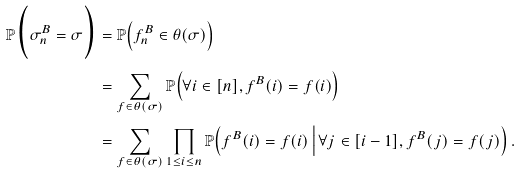<formula> <loc_0><loc_0><loc_500><loc_500>\mathbb { P } \Big ( \sigma ^ { B } _ { n } = \sigma \Big ) & = \mathbb { P } \Big ( f ^ { B } _ { n } \in \theta ( \sigma ) \Big ) \\ & = \sum _ { f \in \theta ( \sigma ) } \mathbb { P } \Big ( \forall i \in [ n ] , f ^ { B } ( i ) = f ( i ) \Big ) \\ & = \sum _ { f \in \theta ( \sigma ) } \prod _ { 1 \leq i \leq n } \mathbb { P } \Big ( f ^ { B } ( i ) = f ( i ) \, \Big | \, \forall j \in [ i - 1 ] , f ^ { B } ( j ) = f ( j ) \Big ) \, .</formula> 